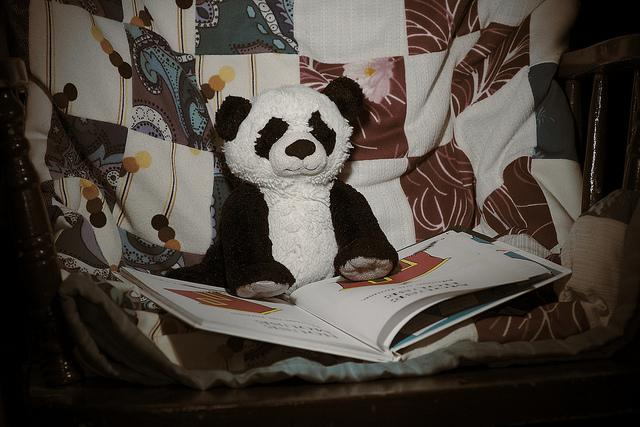Where do pandas come from? Please explain your reasoning. china. A stuffed panda is on a chair in a home. pandas are from china. 